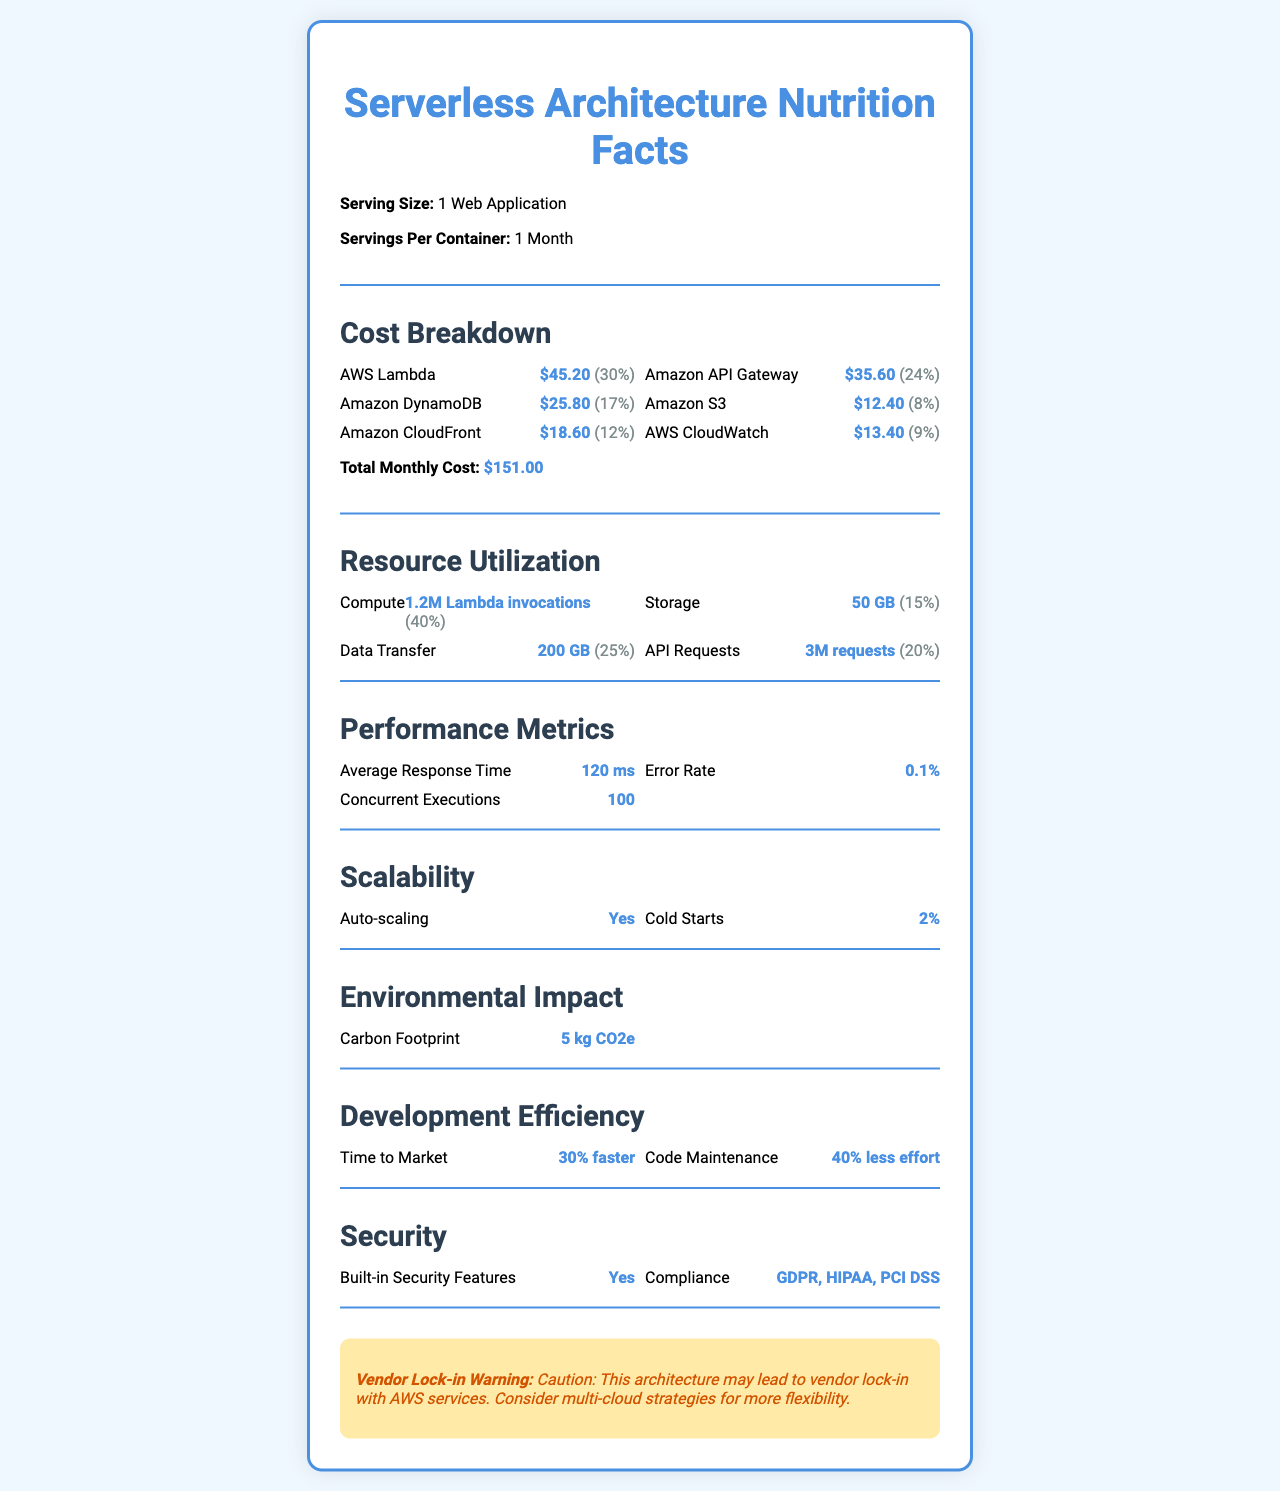how much does AWS Lambda cost per month? The cost breakdown section indicates that AWS Lambda costs $45.20 per month.
Answer: $45.20 which resource has the highest monthly cost? A. AWS Lambda B. Amazon API Gateway C. Amazon DynamoDB D. Amazon CloudFront AWS Lambda has the highest monthly cost at $45.20, surpassing other resources like Amazon API Gateway ($35.60) and Amazon DynamoDB ($25.80).
Answer: A what is the total monthly cost of the web application? The total monthly cost is clearly stated as $151.00 in the cost breakdown section.
Answer: $151.00 how many Lambda invocations occurred over the month? The resource utilization section details that there were 1.2 million Lambda invocations over the month.
Answer: 1.2M Lambda invocations what is the average response time of the web application? The performance metrics section shows that the average response time is 120 milliseconds.
Answer: 120 ms is the web application auto-scaling? The scalability section states that auto-scaling is enabled with 100% daily value.
Answer: Yes how much storage does the web application use? Under resource utilization, it is mentioned that the storage usage is 50 GB.
Answer: 50 GB which resource accounts for 24% of the total cost? A. Amazon S3 B. Amazon API Gateway C. AWS CloudWatch D. Amazon DynamoDB The cost breakdown section indicates that Amazon API Gateway costs $35.60, which is 24% of the total cost.
Answer: B can the error rate be determined from the document? The performance metrics section states that the error rate is 0.1%, making it determinable from the provided information.
Answer: Yes what is the carbon footprint of the web application for the month? The environmental impact section specifies that the carbon footprint is 5 kg CO2e.
Answer: 5 kg CO2e list two compliance certifications mentioned in the document? The security section lists compliance certifications that include GDPR and HIPAA.
Answer: GDPR, HIPAA what is the main idea of the document? The document outlines detailed aspects of the web application such as costs by service, resource usage, and various performance and security metrics, offering a comprehensive look at the monthly operational statistics of a serverless architecture.
Answer: The document provides an overview of the cost breakdown, resource utilization, performance metrics, scalability, environmental impact, development efficiency, and security features of a serverless web application over a month. how much effort is reduced in code maintenance according to the document? The development efficiency section notes that the code maintenance effort is reduced by 40%.
Answer: 40% less effort how many API requests were made over the month? The resource utilization section states that there were 3 million API requests.
Answer: 3M requests does the web application have built-in security features? The security section confirms that the web application has built-in security features with a daily value of 100%.
Answer: Yes can we determine the exact temperature of the server environment from the document? The document provides various operational and performance metrics but does not include any information about the server environment temperature.
Answer: No, this information is not provided. 